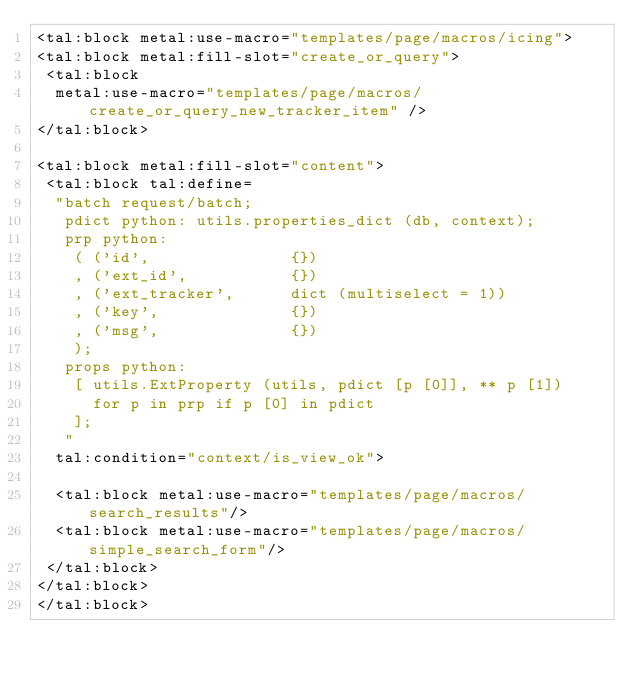Convert code to text. <code><loc_0><loc_0><loc_500><loc_500><_HTML_><tal:block metal:use-macro="templates/page/macros/icing">
<tal:block metal:fill-slot="create_or_query">
 <tal:block 
  metal:use-macro="templates/page/macros/create_or_query_new_tracker_item" />
</tal:block>

<tal:block metal:fill-slot="content">
 <tal:block tal:define=
  "batch request/batch;
   pdict python: utils.properties_dict (db, context);
   prp python:
    ( ('id',               {})
    , ('ext_id',           {})
    , ('ext_tracker',      dict (multiselect = 1))
    , ('key',              {})
    , ('msg',              {})
    );
   props python:
    [ utils.ExtProperty (utils, pdict [p [0]], ** p [1])
      for p in prp if p [0] in pdict
    ];
   "
  tal:condition="context/is_view_ok">

  <tal:block metal:use-macro="templates/page/macros/search_results"/>
  <tal:block metal:use-macro="templates/page/macros/simple_search_form"/>
 </tal:block>
</tal:block>
</tal:block>
</code> 